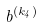<formula> <loc_0><loc_0><loc_500><loc_500>b ^ { ( k _ { 4 } ) }</formula> 